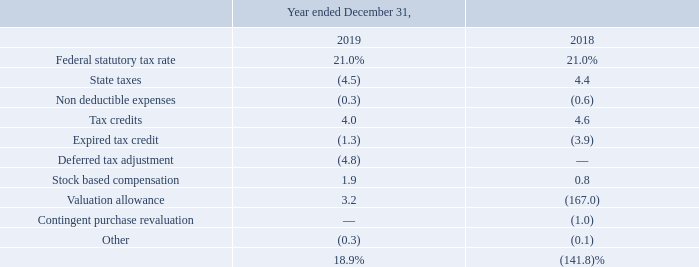The provision for income taxes differed from the provision computed by applying the Federal statutory rate to income (loss) from continuing operations before taxes due to the following:
The effective income tax rate was 18.9% and (141.8)% during the years ended December 31, 2019 and December 31, 2018, respectively. The decrease in 2019 compared to statutory tax rate of 21% was primarily due to deferred tax adjustments related to foreign tax credit carryforwards and state taxes, offset by changes in the valuation allowance and excess tax benefits resulting from the exercise of non-qualified stock options.
The effective tax rate for the year ended December 31,2018 was significantly impacted by recording a substantial increase in a valuation allowance on the entire deferred tax assets.
What was the effective income tax rate during the years ended December 31, 2019 and December 31, 2018 respectively? 18.9%, (141.8)%. What led to the decrease in 2019 compared to statutory tax rate of 21%? Deferred tax adjustments related to foreign tax credit carryforwards and state taxes, offset by changes in the valuation allowance and excess tax benefits resulting from the exercise of non-qualified stock options. What impacted the effective tax rate for the year ended December 31, 2018? By recording a substantial increase in a valuation allowance on the entire deferred tax assets. What is the change in Non deductible expenses between December 31, 2018 and 2019?
Answer scale should be: percent. 0.3-0.6
Answer: -0.3. What is the change in Tax credits from December 31, 2018 and 2019?
Answer scale should be: percent. 4.0-4.6
Answer: -0.6. What is the average Non deductible expenses for December 31, 2018 and 2019?
Answer scale should be: percent. (0.3+0.6) / 2
Answer: 0.45. 